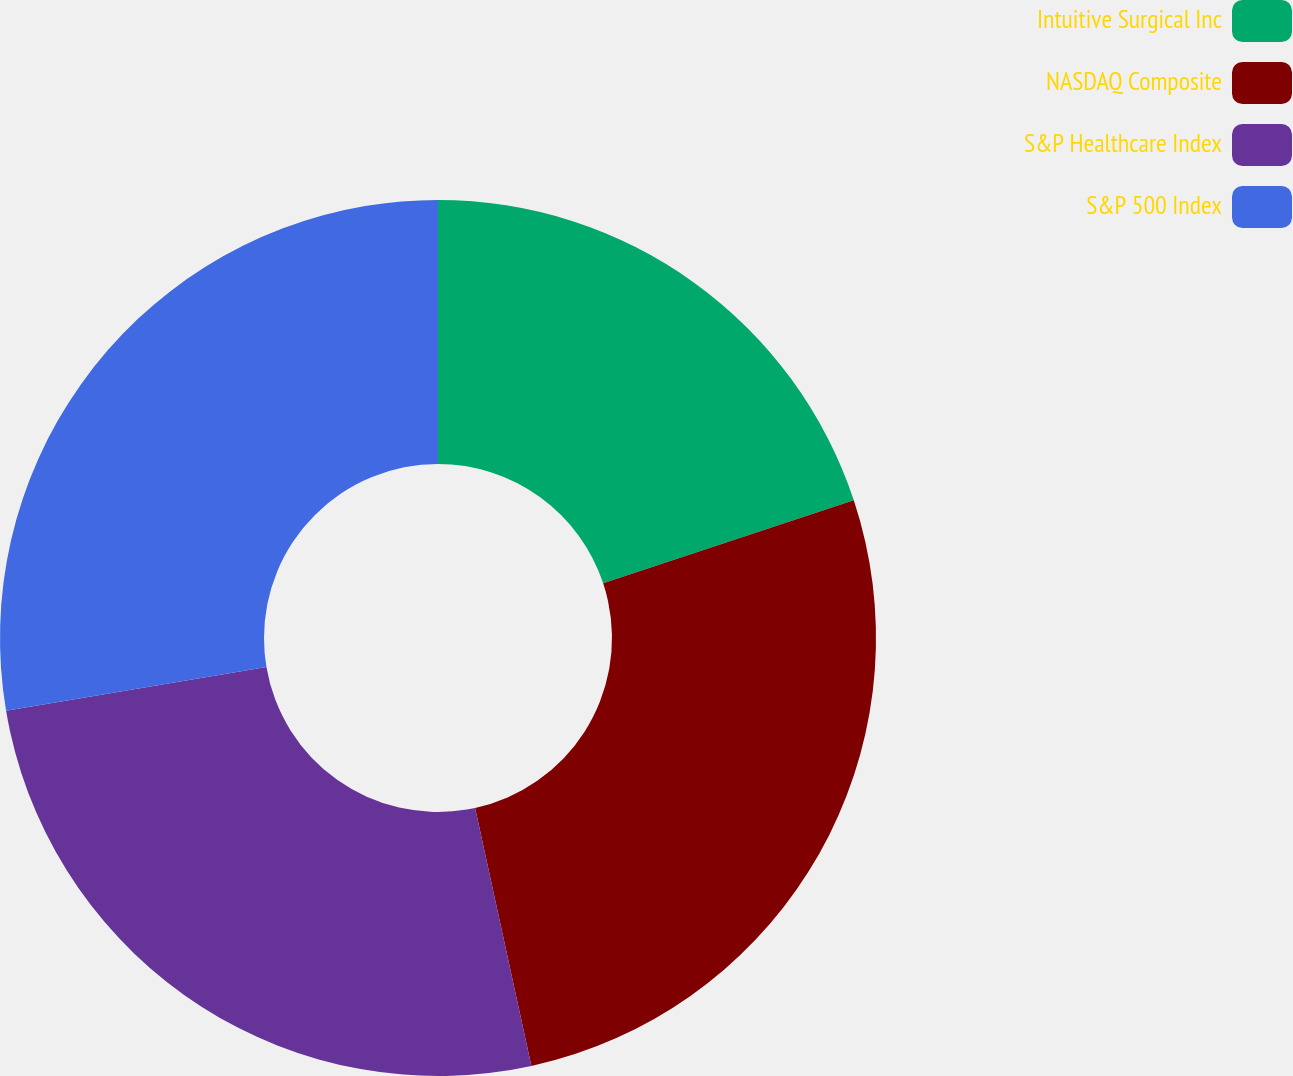Convert chart. <chart><loc_0><loc_0><loc_500><loc_500><pie_chart><fcel>Intuitive Surgical Inc<fcel>NASDAQ Composite<fcel>S&P Healthcare Index<fcel>S&P 500 Index<nl><fcel>19.91%<fcel>26.67%<fcel>25.76%<fcel>27.66%<nl></chart> 